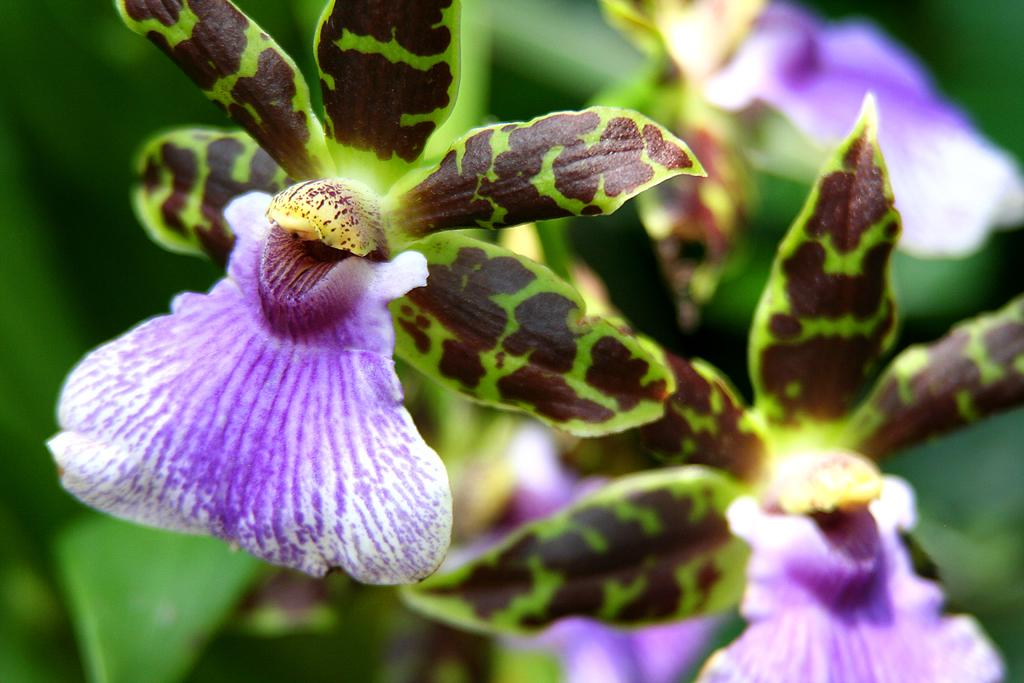What is the main subject of the image? There is a flower in the image. Can you describe the color of the flower? The flower is white and purple in color. What other natural elements can be seen in the image? There is a tree in the image. How would you describe the color of the tree? The tree is green and brown in color. What can be seen in the background of the image? There are flowers and plants in the background of the image. How is the background of the image depicted? The background of the image is blurry. What type of system is being used to control the veil in the image? There is no veil or system present in the image; it features a flower, a tree, and a blurry background. 